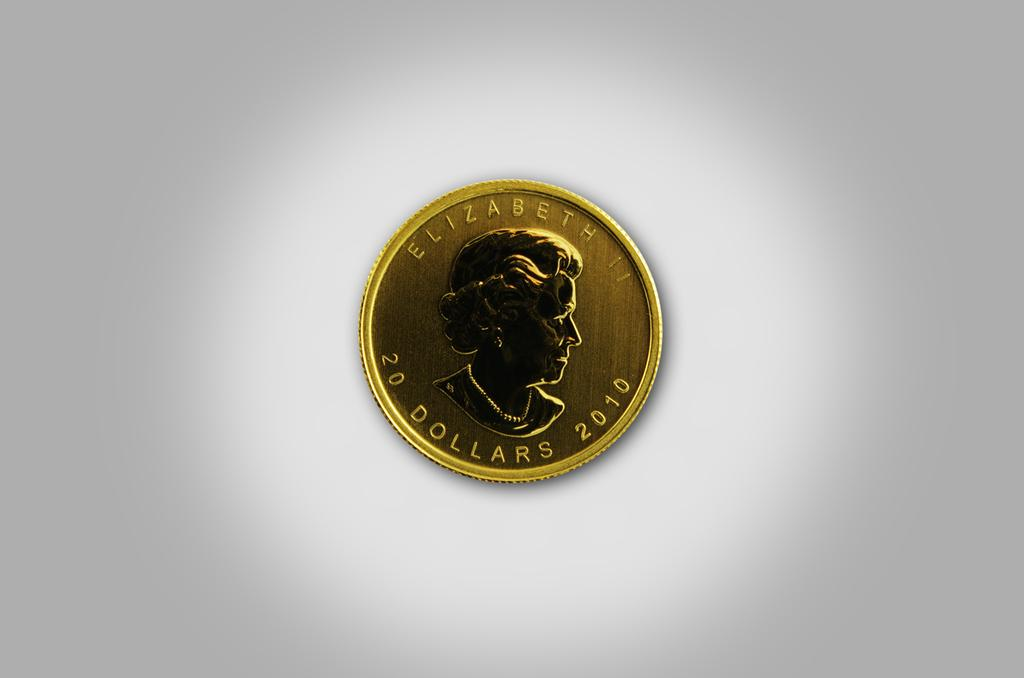<image>
Offer a succinct explanation of the picture presented. Elizabeth 20 dollars, 2010 is stamped into the face of this gold coin. 